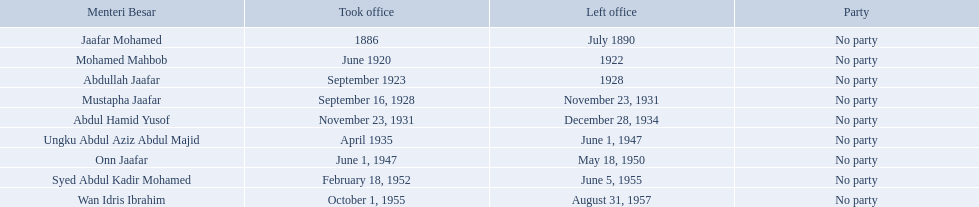Help me parse the entirety of this table. {'header': ['Menteri Besar', 'Took office', 'Left office', 'Party'], 'rows': [['Jaafar Mohamed', '1886', 'July 1890', 'No party'], ['Mohamed Mahbob', 'June 1920', '1922', 'No party'], ['Abdullah Jaafar', 'September 1923', '1928', 'No party'], ['Mustapha Jaafar', 'September 16, 1928', 'November 23, 1931', 'No party'], ['Abdul Hamid Yusof', 'November 23, 1931', 'December 28, 1934', 'No party'], ['Ungku Abdul Aziz Abdul Majid', 'April 1935', 'June 1, 1947', 'No party'], ['Onn Jaafar', 'June 1, 1947', 'May 18, 1950', 'No party'], ['Syed Abdul Kadir Mohamed', 'February 18, 1952', 'June 5, 1955', 'No party'], ['Wan Idris Ibrahim', 'October 1, 1955', 'August 31, 1957', 'No party']]} When did jaafar mohamed take office? 1886. When did mohamed mahbob take office? June 1920. Who was in office no more than 4 years? Mohamed Mahbob. Which menteri besars took office in the 1920's? Mohamed Mahbob, Abdullah Jaafar, Mustapha Jaafar. Of those men, who was only in office for 2 years? Mohamed Mahbob. 